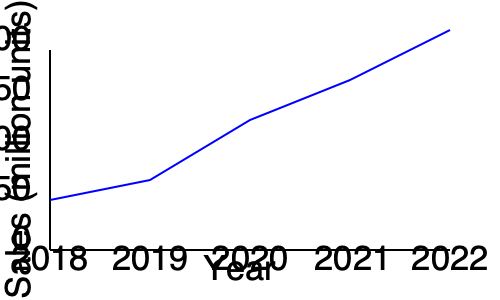Based on the line graph showing bottled water sales trends from 2018 to 2022, what is the estimated percentage increase in sales from 2018 to 2022, and what potential marketing strategies could have contributed to this growth despite concerns about plastic waste? To answer this question, we need to follow these steps:

1. Identify the sales figures for 2018 and 2022:
   - 2018: Approximately 50 million units
   - 2022: Approximately 170 million units

2. Calculate the percentage increase:
   Percentage increase = $\frac{\text{Increase}}{\text{Original Value}} \times 100\%$
   = $\frac{170 - 50}{50} \times 100\%$
   = $\frac{120}{50} \times 100\%$
   = $240\%$

3. Potential marketing strategies that could have contributed to this growth:
   a) Emphasizing health benefits: Promoting bottled water as a healthier alternative to sugary drinks.
   b) Convenience messaging: Highlighting the portability and convenience of bottled water.
   c) Premium branding: Creating high-end bottled water brands to appeal to luxury markets.
   d) Sustainability initiatives: Introducing recycling programs or using partially recycled plastic in bottles to address environmental concerns.
   e) Partnerships with fitness influencers: Associating bottled water with an active, healthy lifestyle.
   f) Limited edition packaging: Creating collectible or seasonally themed bottles to drive sales.
   g) Cause marketing: Aligning with charitable causes, such as clean water initiatives in developing countries.

These strategies could have helped increase sales while addressing some concerns about plastic waste, though the marketing manager may still have personal reservations about the environmental impact.
Answer: 240% increase; strategies include health benefits promotion, convenience messaging, premium branding, sustainability initiatives, influencer partnerships, limited edition packaging, and cause marketing. 